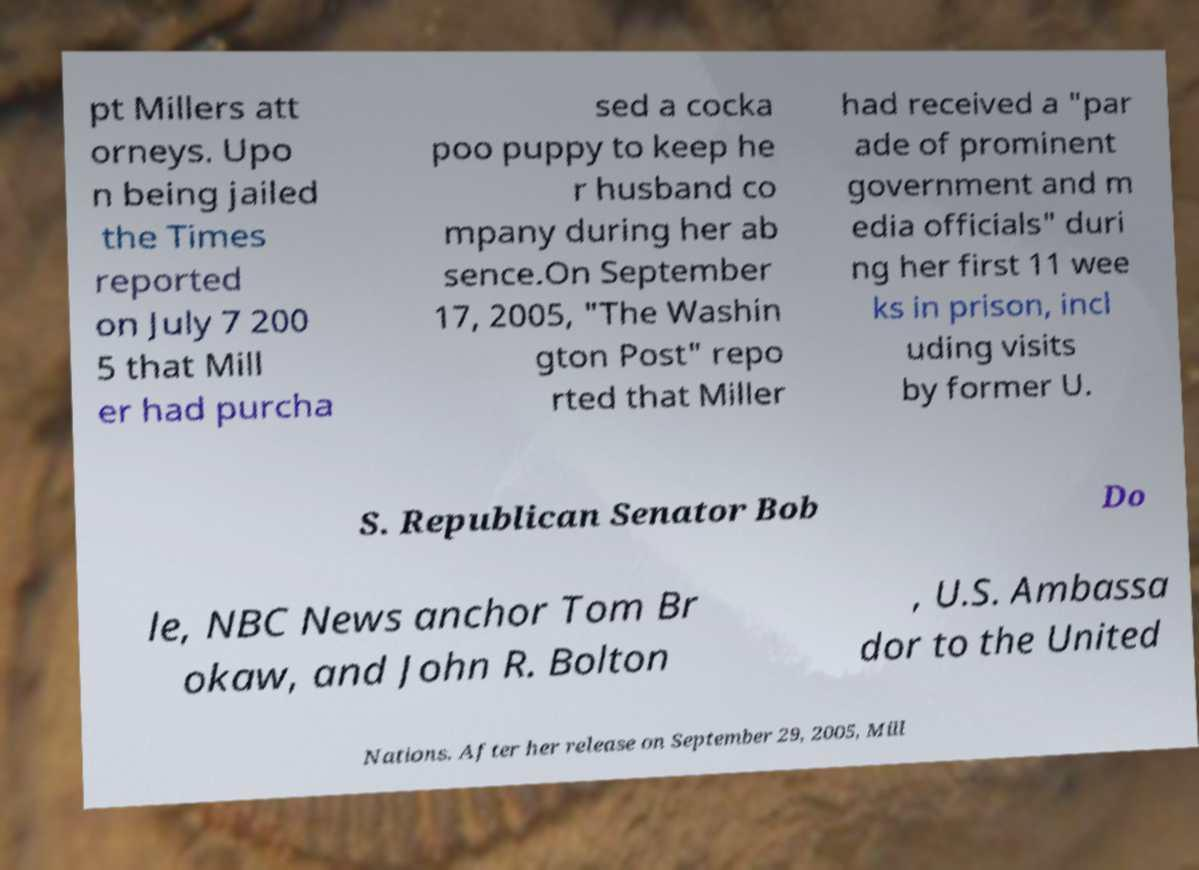Could you extract and type out the text from this image? pt Millers att orneys. Upo n being jailed the Times reported on July 7 200 5 that Mill er had purcha sed a cocka poo puppy to keep he r husband co mpany during her ab sence.On September 17, 2005, "The Washin gton Post" repo rted that Miller had received a "par ade of prominent government and m edia officials" duri ng her first 11 wee ks in prison, incl uding visits by former U. S. Republican Senator Bob Do le, NBC News anchor Tom Br okaw, and John R. Bolton , U.S. Ambassa dor to the United Nations. After her release on September 29, 2005, Mill 